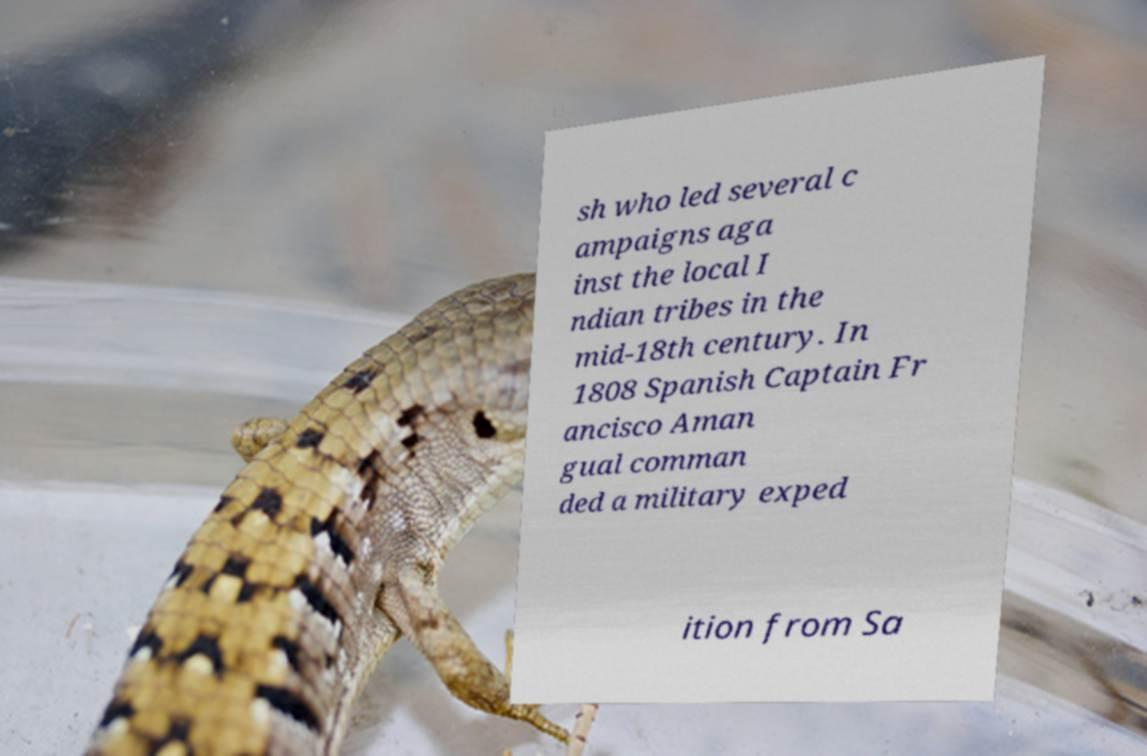There's text embedded in this image that I need extracted. Can you transcribe it verbatim? sh who led several c ampaigns aga inst the local I ndian tribes in the mid-18th century. In 1808 Spanish Captain Fr ancisco Aman gual comman ded a military exped ition from Sa 